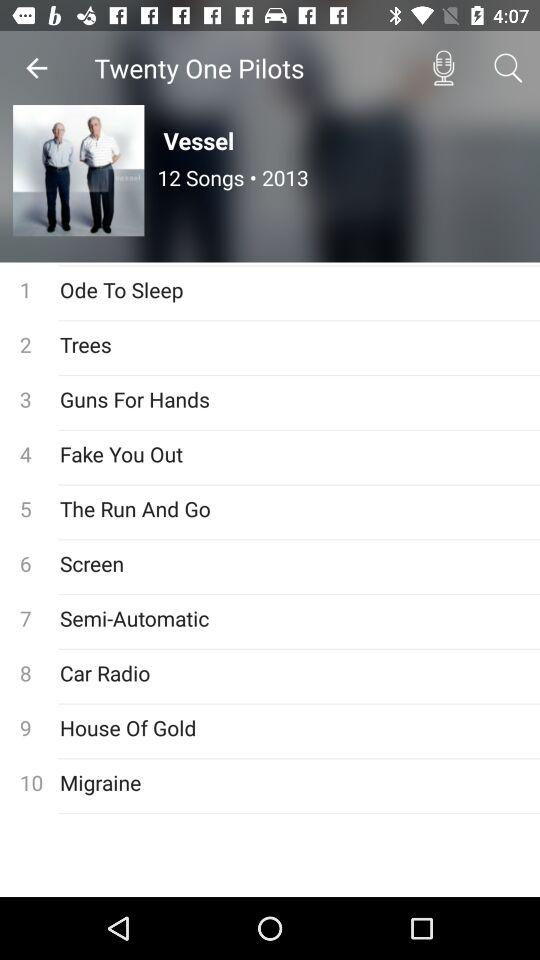How many songs are there in the album "Vessel"? There are 12 songs in the album "Vessel". 